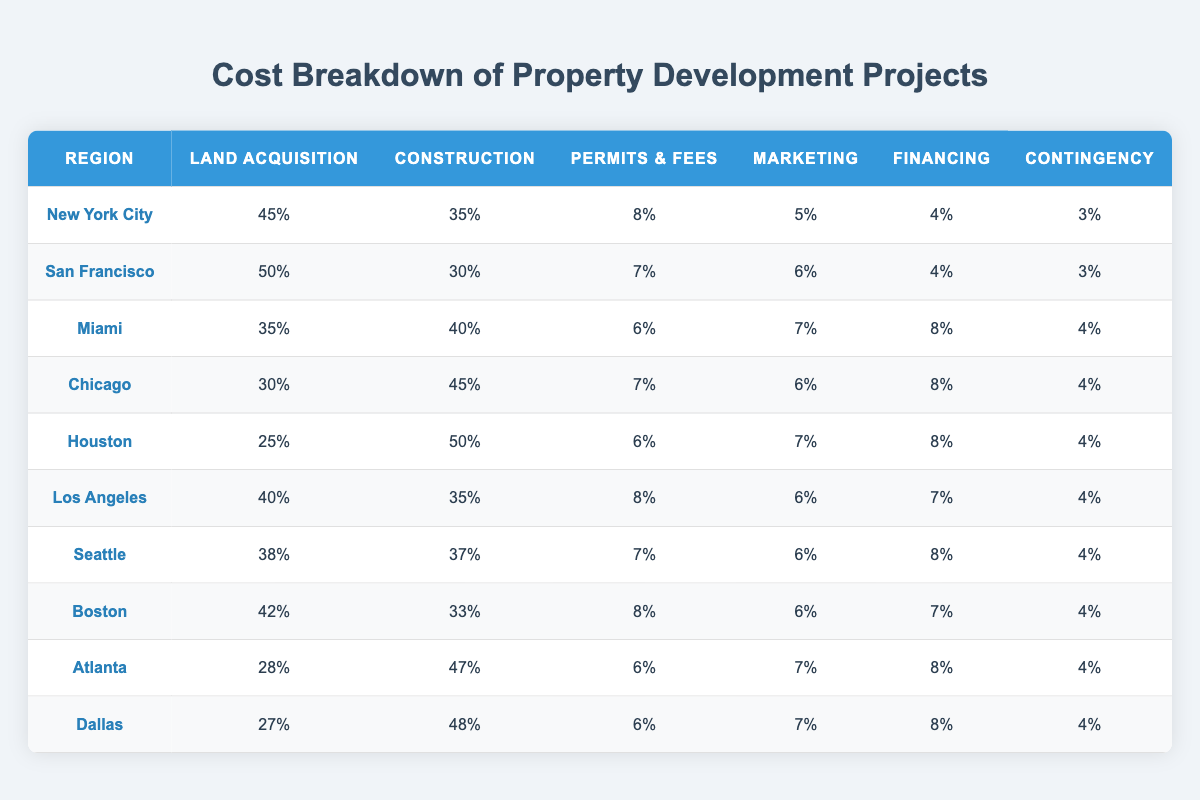What percentage of costs in Miami is attributable to construction? In Miami, the cost breakdown shows that 40% of the total costs are attributed to construction, as stated clearly in the table.
Answer: 40% Which region has the highest percentage of land acquisition costs? According to the table, San Francisco has the highest land acquisition cost at 50%, as it is the only region listed with this percentage.
Answer: San Francisco Is the financing cost in Houston higher than in Los Angeles? In Houston, the financing cost is 8%, while in Los Angeles it is 7%. Therefore, the financing cost in Houston is indeed higher than in Los Angeles.
Answer: Yes What is the average percentage of contingency costs across all regions? To calculate the average contingency cost, we add up the contingency percentages across all regions (3% + 3% + 4% + 4% + 4% + 4% + 4% + 4% + 4% + 4% = 39%) and then divide by the number of regions (10), resulting in an average of 39% / 10 = 3.9%.
Answer: 3.9% Which region has the lowest marketing costs? By examining the marketing percentages in the table, we can see that Atlanta has the lowest marketing cost at 7%, as it is the smallest percentage listed for that category.
Answer: Atlanta If we sum the construction cost percentages across all regions, what is the total? The total construction cost percentages are calculated by adding them up: 35% + 30% + 40% + 45% + 50% + 35% + 37% + 33% + 47% + 48% = 420%. Then, we observe that this is the total percentage for construction costs across the regions.
Answer: 420% Does Boston have a higher percentage for permits and fees compared to Miami? In Boston, the percentage for permits and fees is 8%, while Miami reports 6%. Therefore, Boston does have a higher percentage for permits and fees compared to Miami.
Answer: Yes Which region has the most balanced cost distribution across all categories? To assess the balance, we can analyze the percentages across regions. Houston shows a relatively even distribution: Land Acquisition: 25%, Construction: 50%, Permits & Fees: 6%, Marketing: 7%, Financing: 8%, and Contingency: 4%. No other regions have an apparent balance across all categories as closely as Houston.
Answer: Houston What is the difference in land acquisition costs between New York City and Chicago? The land acquisition cost in New York City is 45%, whereas in Chicago it is 30%. To find the difference, we subtract: 45% - 30% = 15%. This indicates that land acquisition costs are 15% higher in New York City than in Chicago.
Answer: 15% 